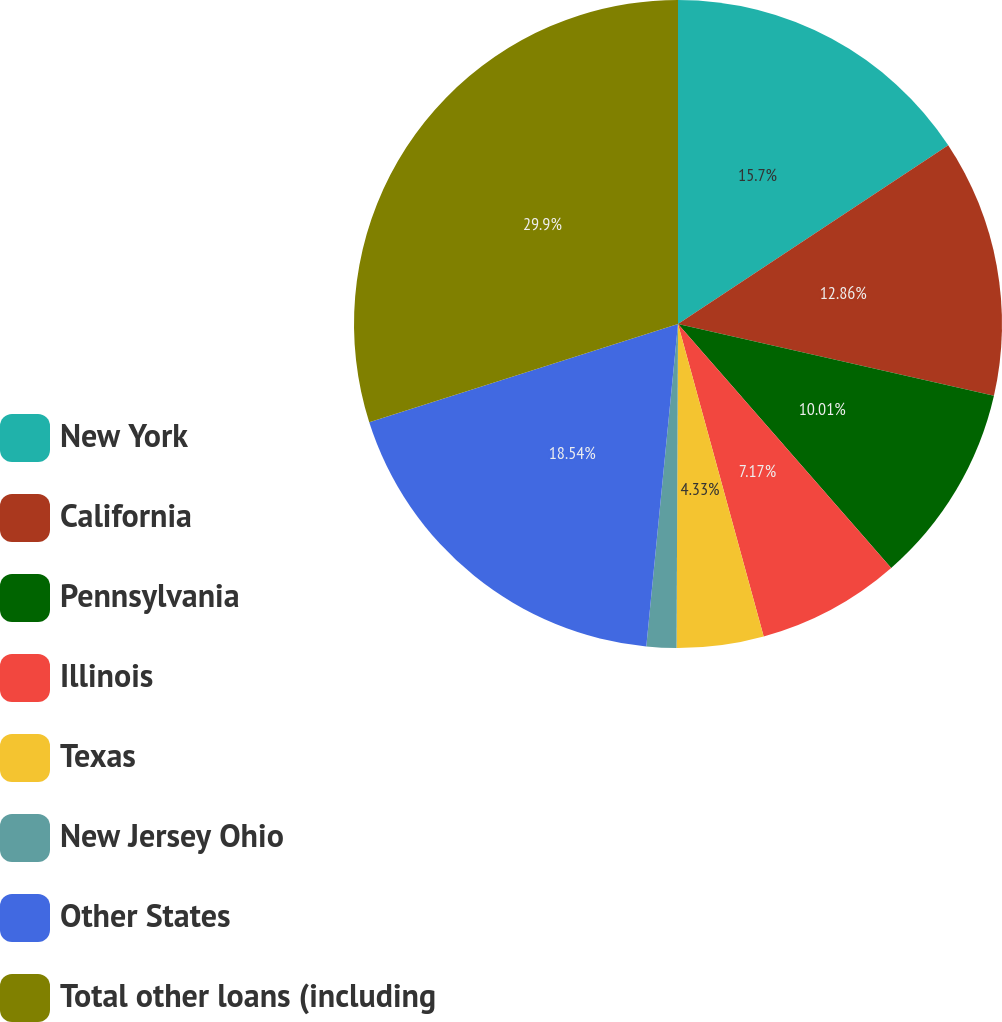<chart> <loc_0><loc_0><loc_500><loc_500><pie_chart><fcel>New York<fcel>California<fcel>Pennsylvania<fcel>Illinois<fcel>Texas<fcel>New Jersey Ohio<fcel>Other States<fcel>Total other loans (including<nl><fcel>15.7%<fcel>12.86%<fcel>10.01%<fcel>7.17%<fcel>4.33%<fcel>1.49%<fcel>18.54%<fcel>29.9%<nl></chart> 